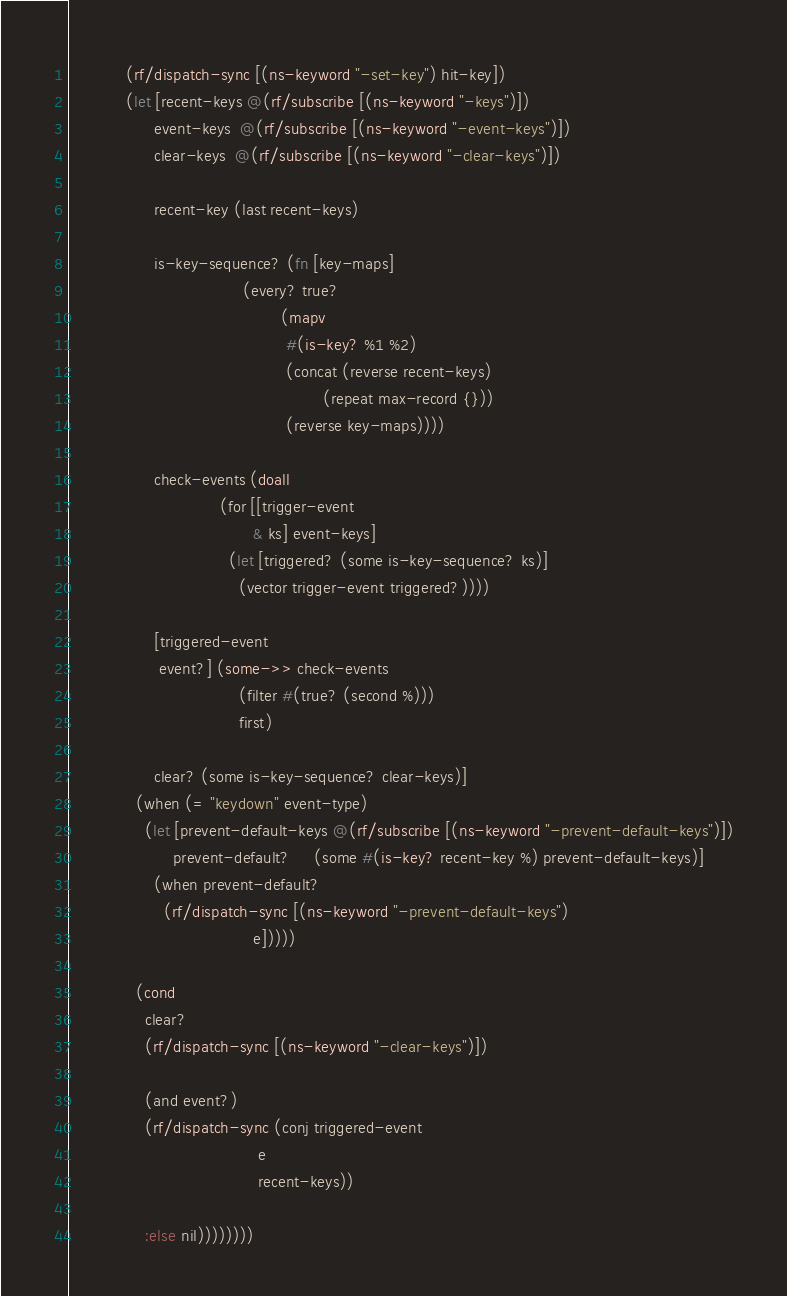<code> <loc_0><loc_0><loc_500><loc_500><_Clojure_>            (rf/dispatch-sync [(ns-keyword "-set-key") hit-key])
            (let [recent-keys @(rf/subscribe [(ns-keyword "-keys")])
                  event-keys  @(rf/subscribe [(ns-keyword "-event-keys")])
                  clear-keys  @(rf/subscribe [(ns-keyword "-clear-keys")])

                  recent-key (last recent-keys)

                  is-key-sequence? (fn [key-maps]
                                     (every? true?
                                             (mapv
                                              #(is-key? %1 %2)
                                              (concat (reverse recent-keys)
                                                      (repeat max-record {}))
                                              (reverse key-maps))))

                  check-events (doall
                                (for [[trigger-event
                                       & ks] event-keys]
                                  (let [triggered? (some is-key-sequence? ks)]
                                    (vector trigger-event triggered?))))

                  [triggered-event
                   event?] (some->> check-events
                                    (filter #(true? (second %)))
                                    first)

                  clear? (some is-key-sequence? clear-keys)]
              (when (= "keydown" event-type)
                (let [prevent-default-keys @(rf/subscribe [(ns-keyword "-prevent-default-keys")])
                      prevent-default?     (some #(is-key? recent-key %) prevent-default-keys)]
                  (when prevent-default?
                    (rf/dispatch-sync [(ns-keyword "-prevent-default-keys")
                                       e]))))

              (cond
                clear?
                (rf/dispatch-sync [(ns-keyword "-clear-keys")])

                (and event?)
                (rf/dispatch-sync (conj triggered-event
                                        e
                                        recent-keys))

                :else nil))))))))
</code> 